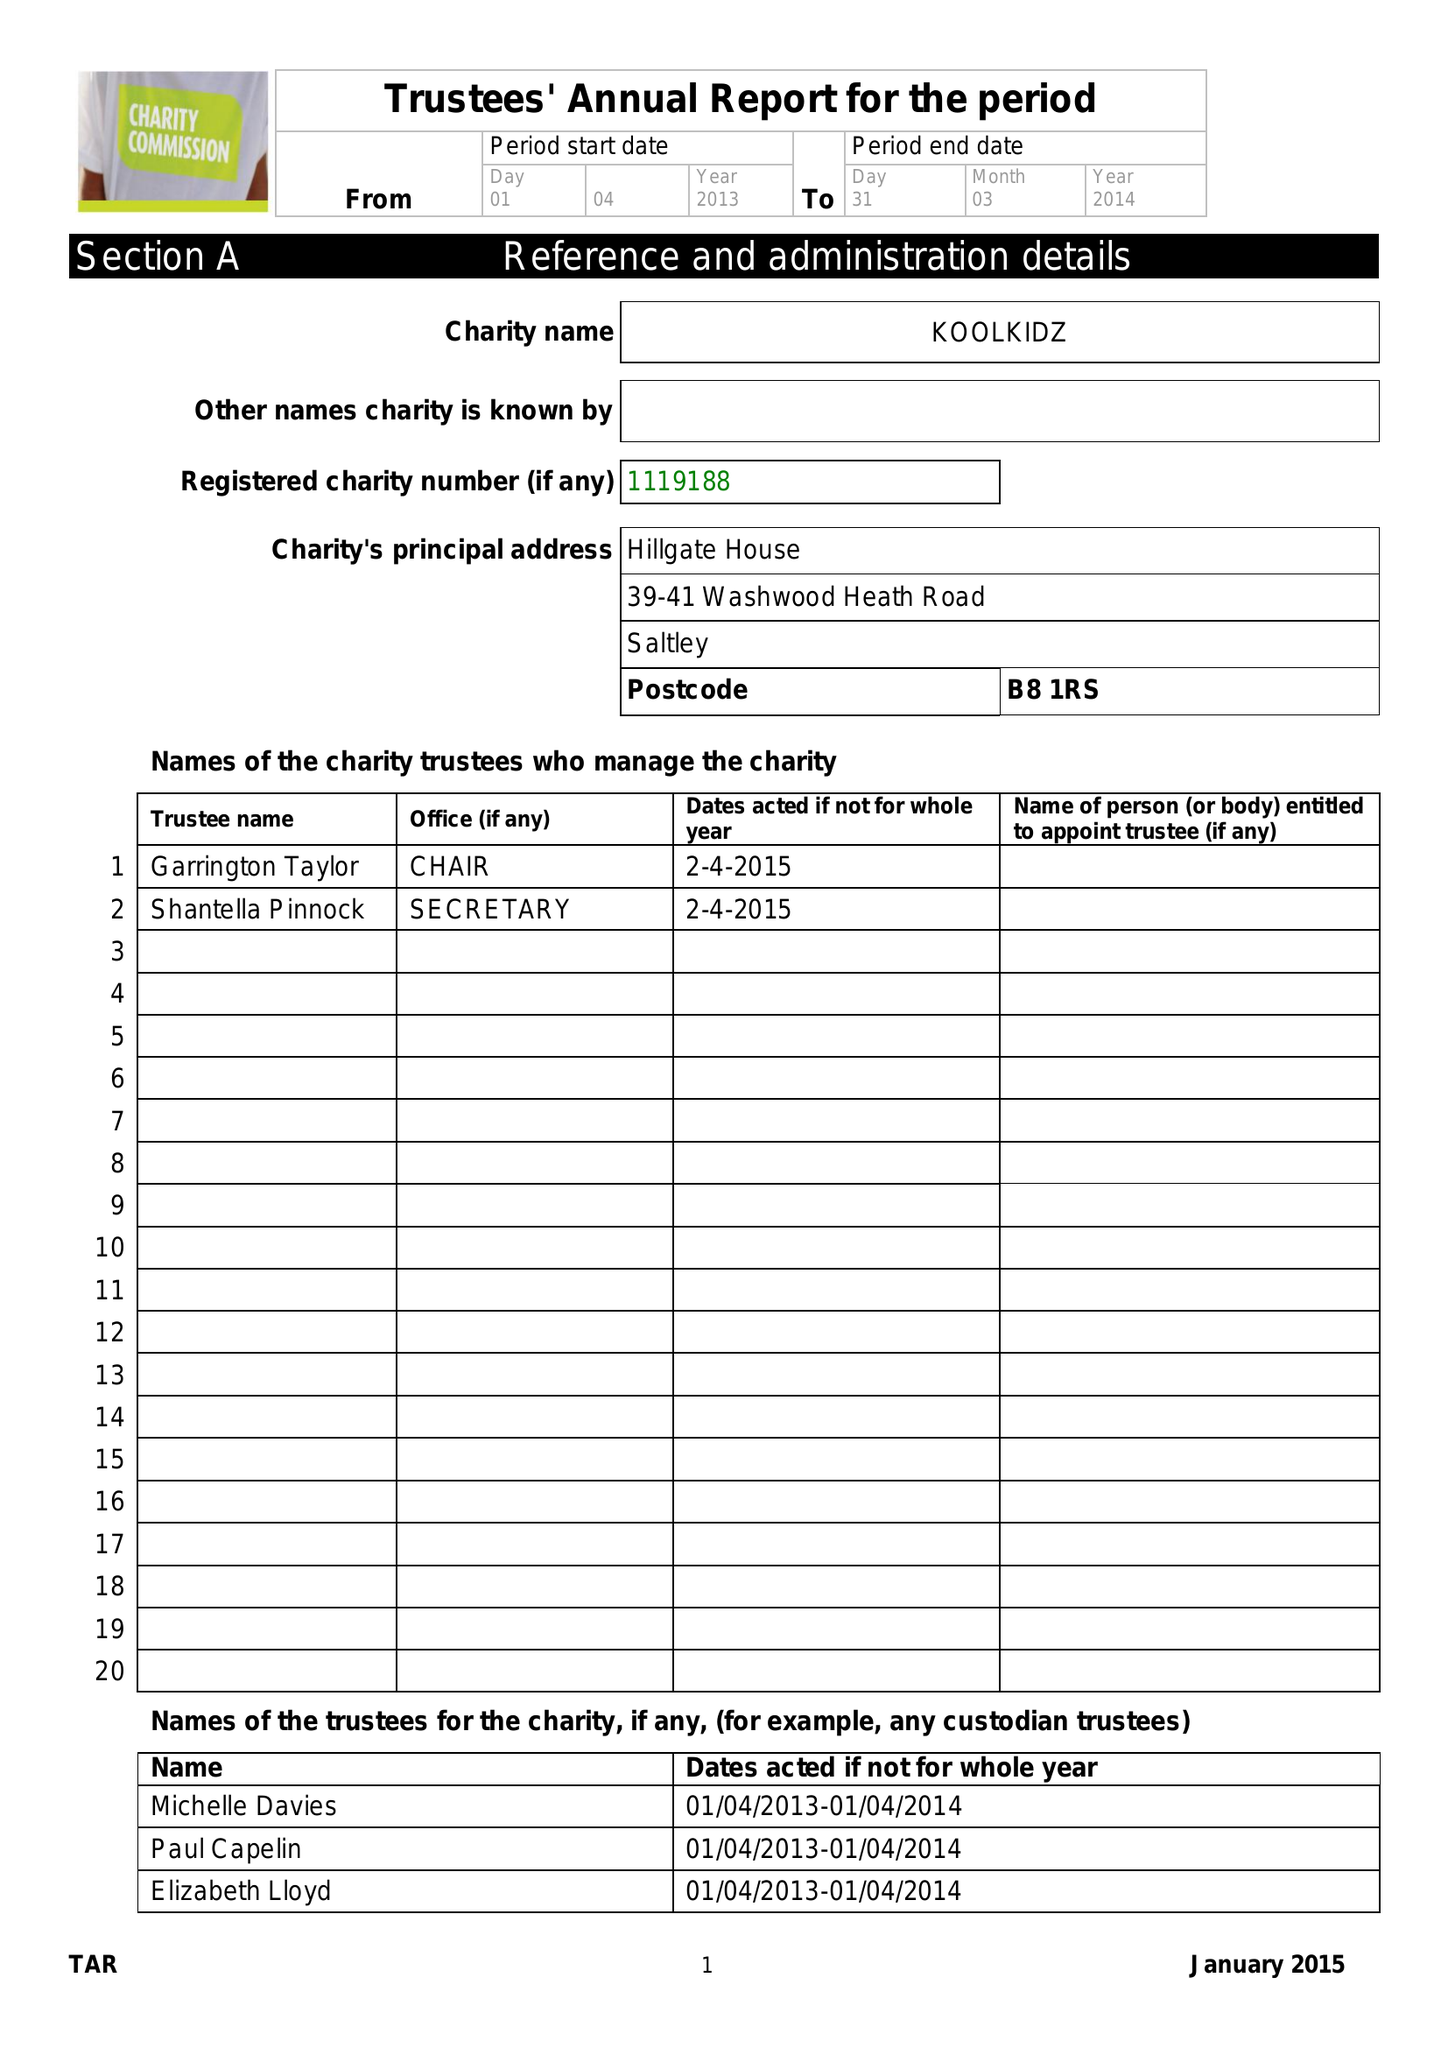What is the value for the address__post_town?
Answer the question using a single word or phrase. BIRMINGHAM 